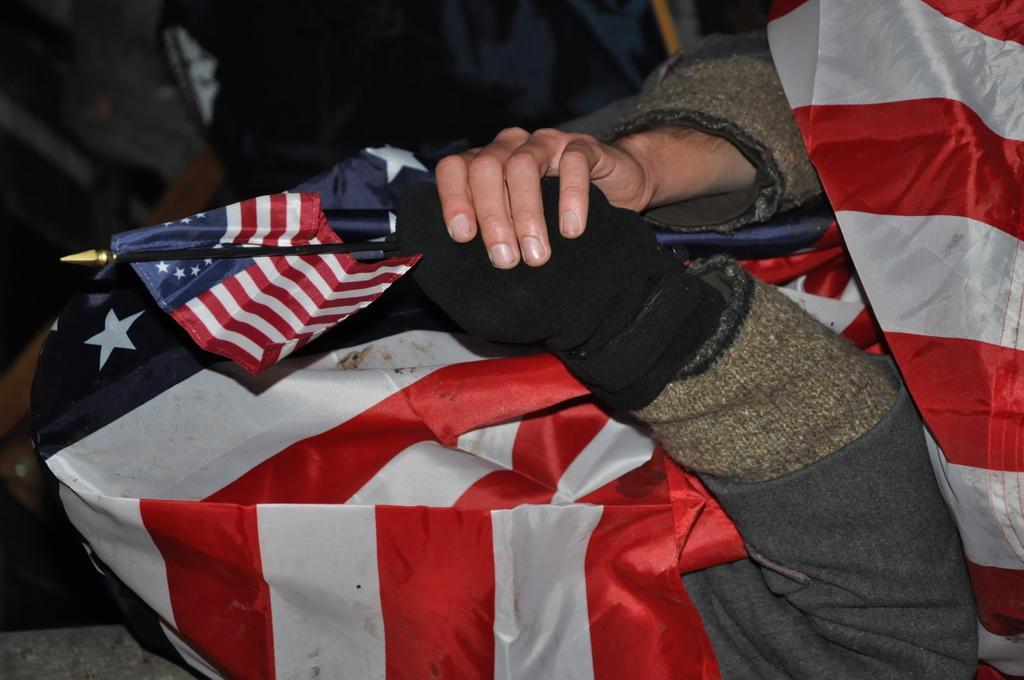Can you describe this image briefly? In this image, we can see a person's hands holding a flag. We can also see a cloth. 